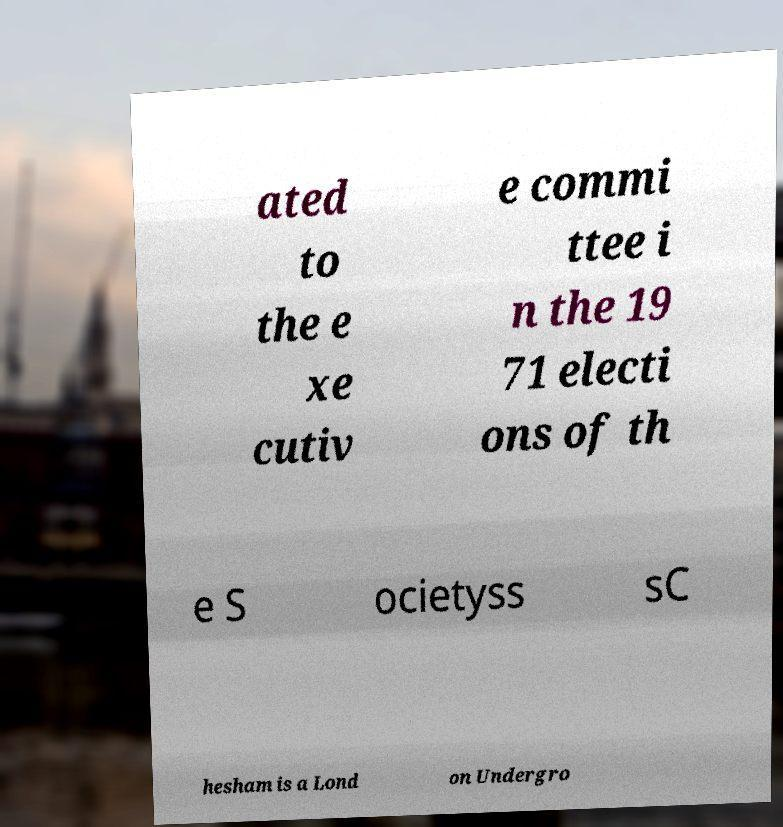What messages or text are displayed in this image? I need them in a readable, typed format. ated to the e xe cutiv e commi ttee i n the 19 71 electi ons of th e S ocietyss sC hesham is a Lond on Undergro 